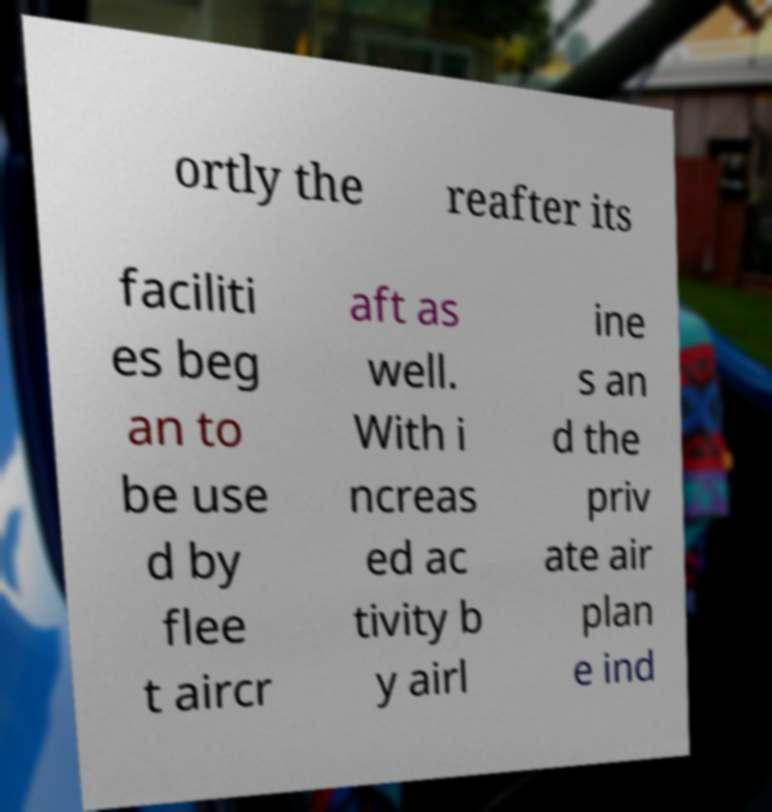What messages or text are displayed in this image? I need them in a readable, typed format. ortly the reafter its faciliti es beg an to be use d by flee t aircr aft as well. With i ncreas ed ac tivity b y airl ine s an d the priv ate air plan e ind 